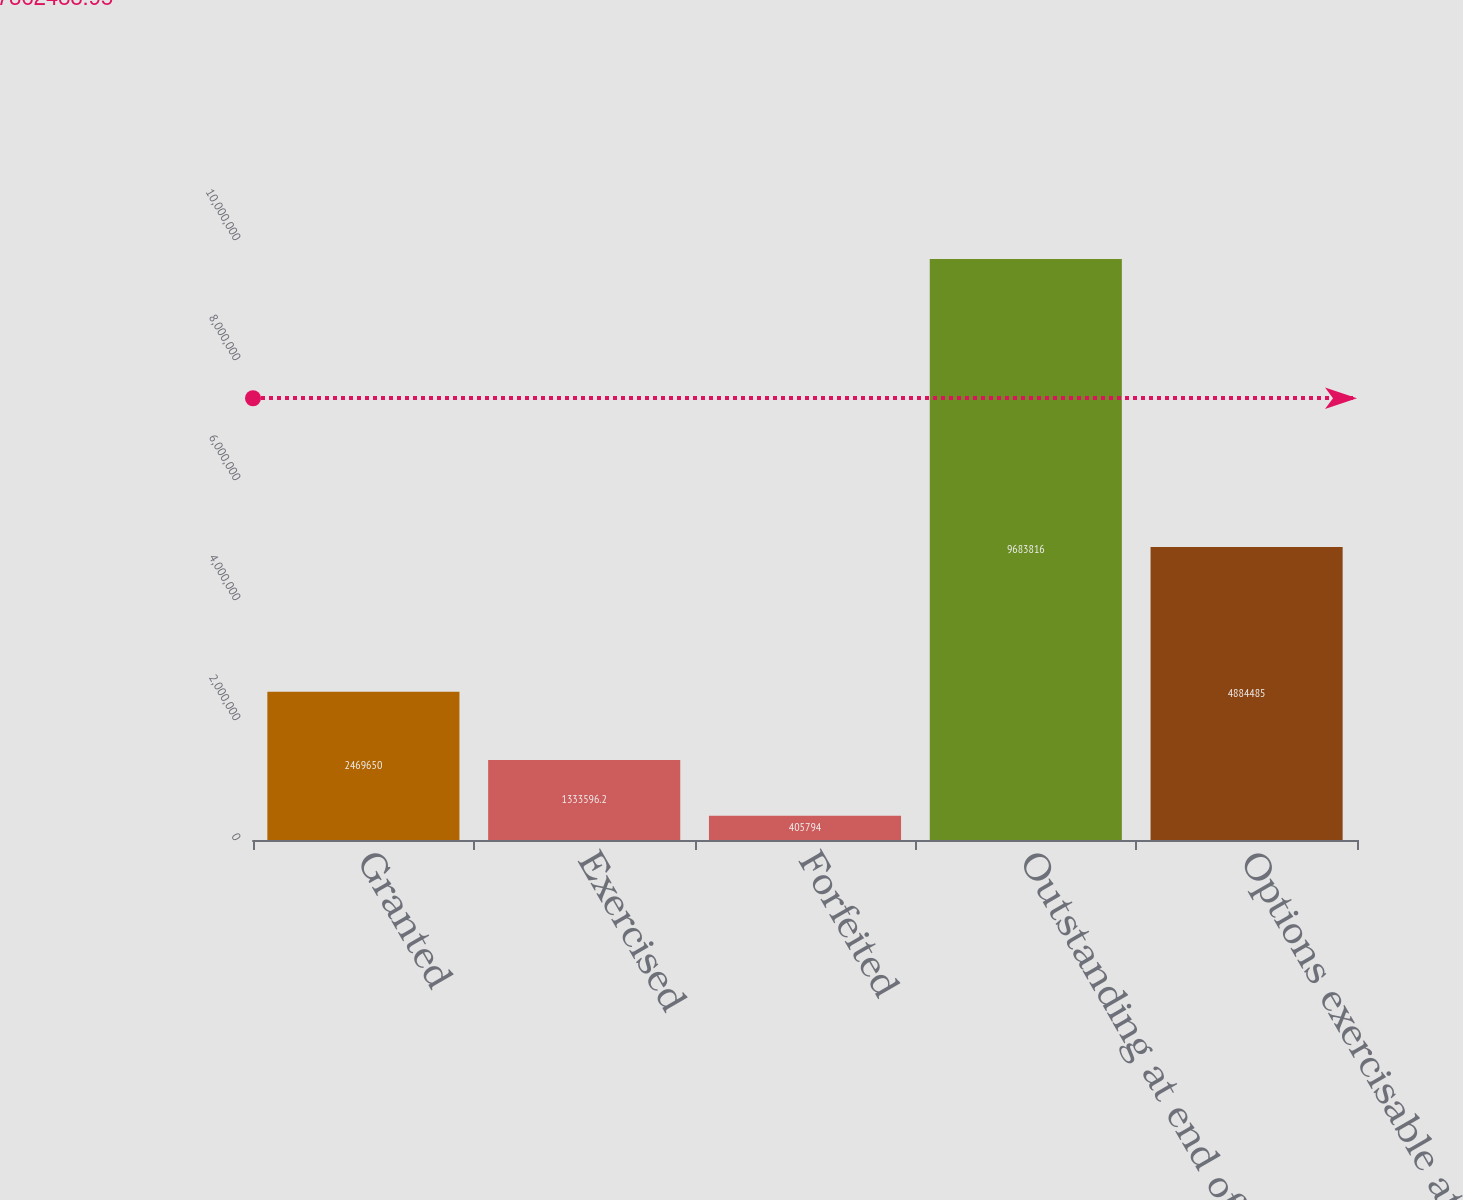<chart> <loc_0><loc_0><loc_500><loc_500><bar_chart><fcel>Granted<fcel>Exercised<fcel>Forfeited<fcel>Outstanding at end of year<fcel>Options exercisable at end of<nl><fcel>2.46965e+06<fcel>1.3336e+06<fcel>405794<fcel>9.68382e+06<fcel>4.88448e+06<nl></chart> 